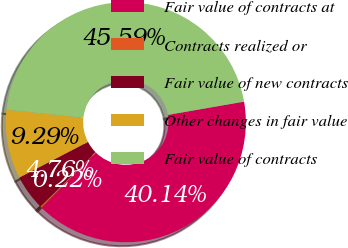<chart> <loc_0><loc_0><loc_500><loc_500><pie_chart><fcel>Fair value of contracts at<fcel>Contracts realized or<fcel>Fair value of new contracts<fcel>Other changes in fair value<fcel>Fair value of contracts<nl><fcel>40.14%<fcel>0.22%<fcel>4.76%<fcel>9.29%<fcel>45.59%<nl></chart> 